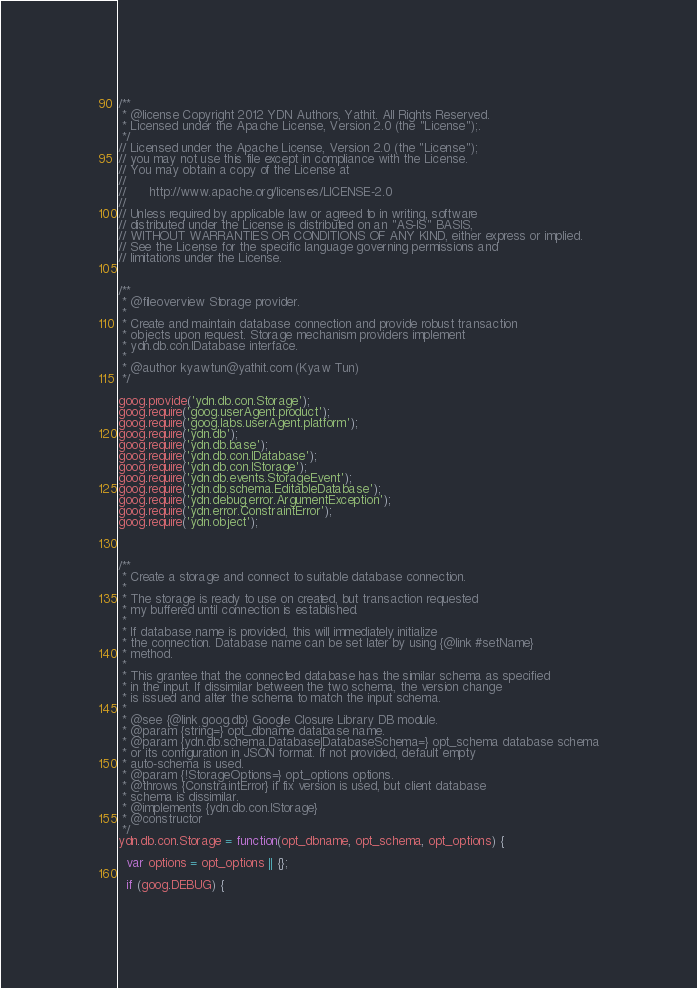Convert code to text. <code><loc_0><loc_0><loc_500><loc_500><_JavaScript_>/**
 * @license Copyright 2012 YDN Authors, Yathit. All Rights Reserved.
 * Licensed under the Apache License, Version 2.0 (the "License");.
 */
// Licensed under the Apache License, Version 2.0 (the "License");
// you may not use this file except in compliance with the License.
// You may obtain a copy of the License at
//
//      http://www.apache.org/licenses/LICENSE-2.0
//
// Unless required by applicable law or agreed to in writing, software
// distributed under the License is distributed on an "AS-IS" BASIS,
// WITHOUT WARRANTIES OR CONDITIONS OF ANY KIND, either express or implied.
// See the License for the specific language governing permissions and
// limitations under the License.


/**
 * @fileoverview Storage provider.
 *
 * Create and maintain database connection and provide robust transaction
 * objects upon request. Storage mechanism providers implement
 * ydn.db.con.IDatabase interface.
 *
 * @author kyawtun@yathit.com (Kyaw Tun)
 */

goog.provide('ydn.db.con.Storage');
goog.require('goog.userAgent.product');
goog.require('goog.labs.userAgent.platform');
goog.require('ydn.db');
goog.require('ydn.db.base');
goog.require('ydn.db.con.IDatabase');
goog.require('ydn.db.con.IStorage');
goog.require('ydn.db.events.StorageEvent');
goog.require('ydn.db.schema.EditableDatabase');
goog.require('ydn.debug.error.ArgumentException');
goog.require('ydn.error.ConstraintError');
goog.require('ydn.object');



/**
 * Create a storage and connect to suitable database connection.
 *
 * The storage is ready to use on created, but transaction requested
 * my buffered until connection is established.
 *
 * If database name is provided, this will immediately initialize
 * the connection. Database name can be set later by using {@link #setName}
 * method.
 *
 * This grantee that the connected database has the similar schema as specified
 * in the input. If dissimilar between the two schema, the version change
 * is issued and alter the schema to match the input schema.
 *
 * @see {@link goog.db} Google Closure Library DB module.
 * @param {string=} opt_dbname database name.
 * @param {ydn.db.schema.Database|DatabaseSchema=} opt_schema database schema
 * or its configuration in JSON format. If not provided, default empty
 * auto-schema is used.
 * @param {!StorageOptions=} opt_options options.
 * @throws {ConstraintError} if fix version is used, but client database
 * schema is dissimilar.
 * @implements {ydn.db.con.IStorage}
 * @constructor
 */
ydn.db.con.Storage = function(opt_dbname, opt_schema, opt_options) {

  var options = opt_options || {};

  if (goog.DEBUG) {</code> 